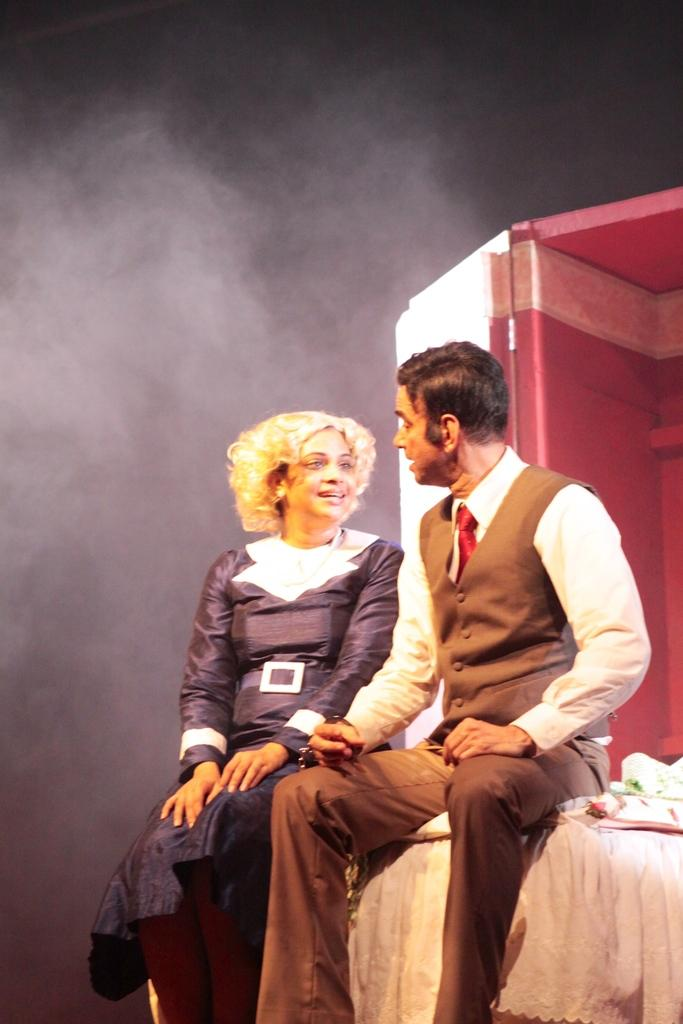How many people are in the image? There are two persons sitting in the image. What is the color of the object behind the persons? The object behind the persons is red. What is the color of the background in the image? The background of the image is black. What type of pencil is being used to write a story in the image? There is no pencil or story present in the image. 